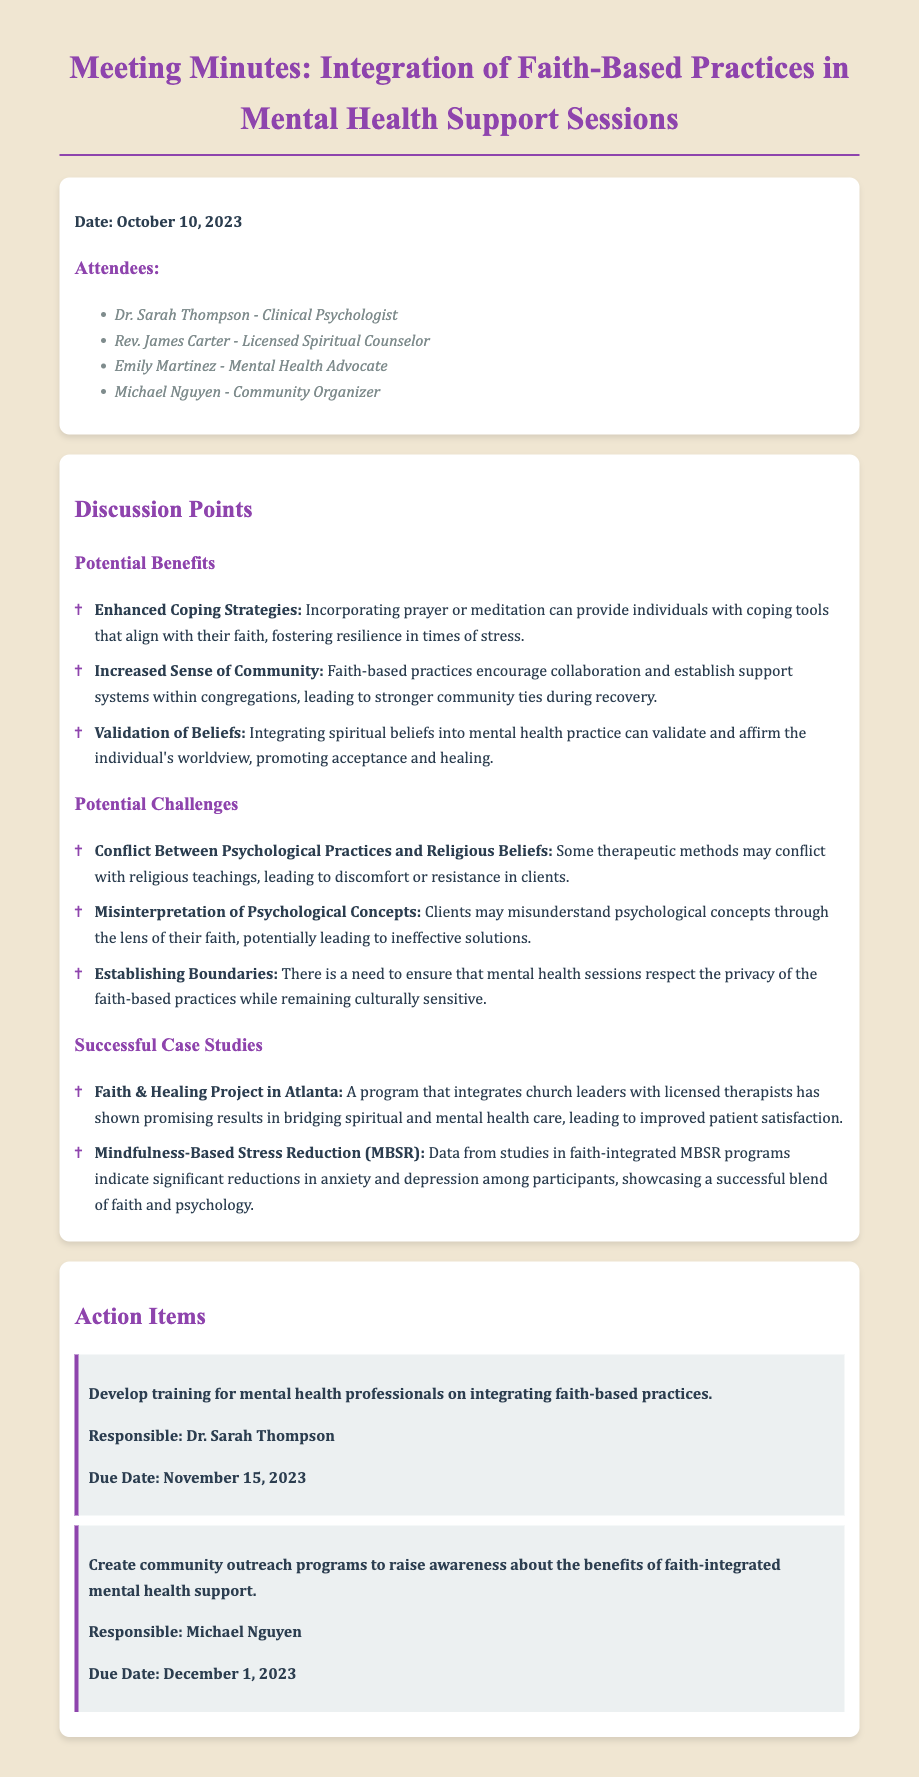What is the date of the meeting? The date of the meeting is specified in the document's header section.
Answer: October 10, 2023 Who is responsible for developing training for mental health professionals? The document lists specific responsibilities assigned to attendees in the action items section.
Answer: Dr. Sarah Thompson What is one potential benefit of integrating faith into mental health support? The benefits section highlights various positive aspects of integrating faith, which could be noted for understanding.
Answer: Enhanced Coping Strategies What is one of the potential challenges mentioned? The challenges section identifies issues that may arise when combining faith and mental health support.
Answer: Conflict Between Psychological Practices and Religious Beliefs What is the title of the successful case study related to a program in Atlanta? The case studies section describes different successful integrations of faith and mental health practices.
Answer: Faith & Healing Project in Atlanta What is the due date for the community outreach programs action item? Each action item in the document includes a specified due date related to its completion.
Answer: December 1, 2023 How many attendees are listed in the meeting minutes? The attendees section enumerates all present members, which can be counted for understanding participation.
Answer: Four What is the emphasis of the "Mindfulness-Based Stress Reduction" case study? The case studies section gives insight into various successful practices integrating faith and psychology.
Answer: Significant reductions in anxiety and depression among participants 